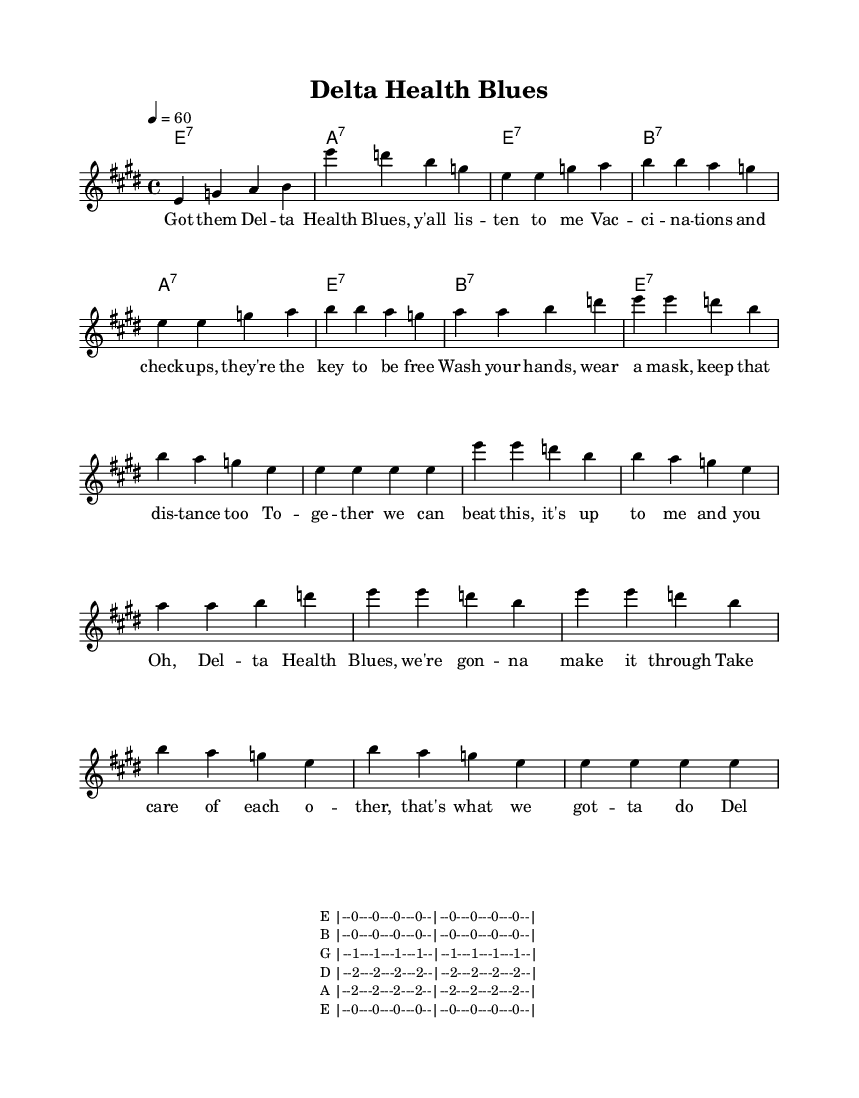What is the key signature of this music? The key signature is E major, which has four sharps (F#, C#, G#, D#).
Answer: E major What is the time signature of this music? The time signature is 4/4, indicating four beats per measure, and the quarter note gets one beat.
Answer: 4/4 What is the tempo marking of this music? The tempo marking indicates a speed of sixty beats per minute (60 BPM).
Answer: 60 How many measures are in the verse? The verse consists of four measures, seen at the beginning of the verse section.
Answer: Four measures What is the structure of the song? The song follows a structure of verses followed by a chorus, alternating several times.
Answer: Verse, chorus What chord progression is primarily used in the harmony? The chord progression used is E7, A7, and B7, typical of Delta blues music.
Answer: E7, A7, B7 How does the lyrical theme relate to community health? The lyrics emphasize health awareness, vaccination, and community support during health challenges.
Answer: Health awareness 